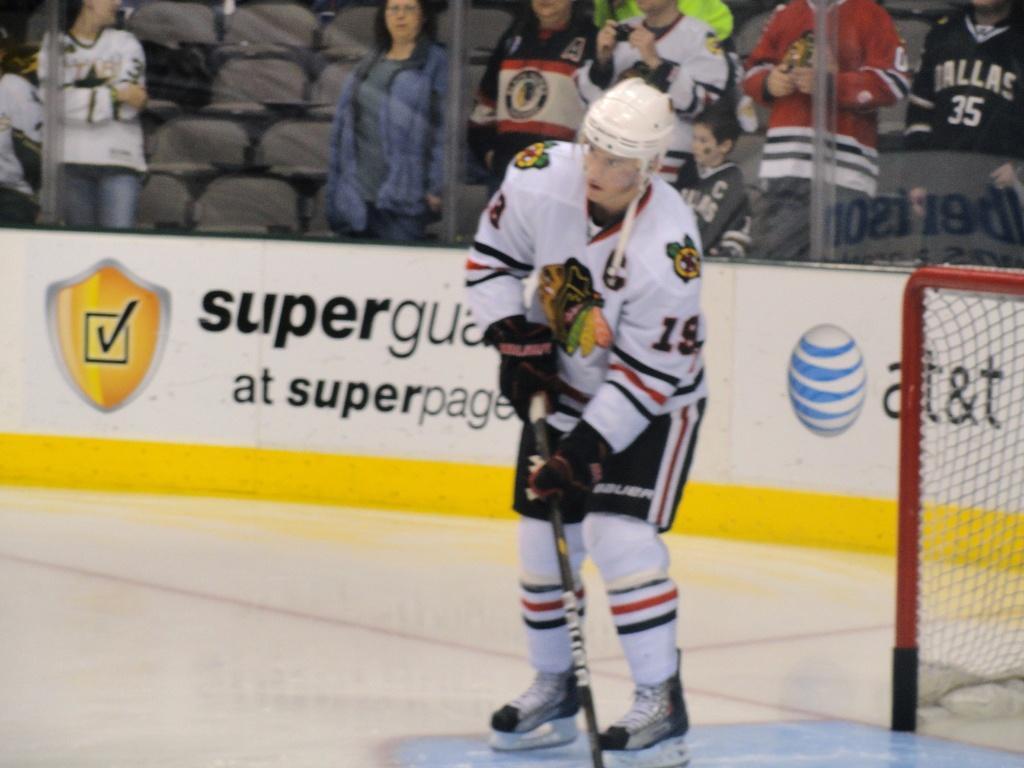Describe this image in one or two sentences. This picture looks like a stadium, in this image we can see a person holding a hockey stick on the ground, behind them, we can see a board with some text and images, also we can see a net, in the background we can see some chairs, poles and people. 